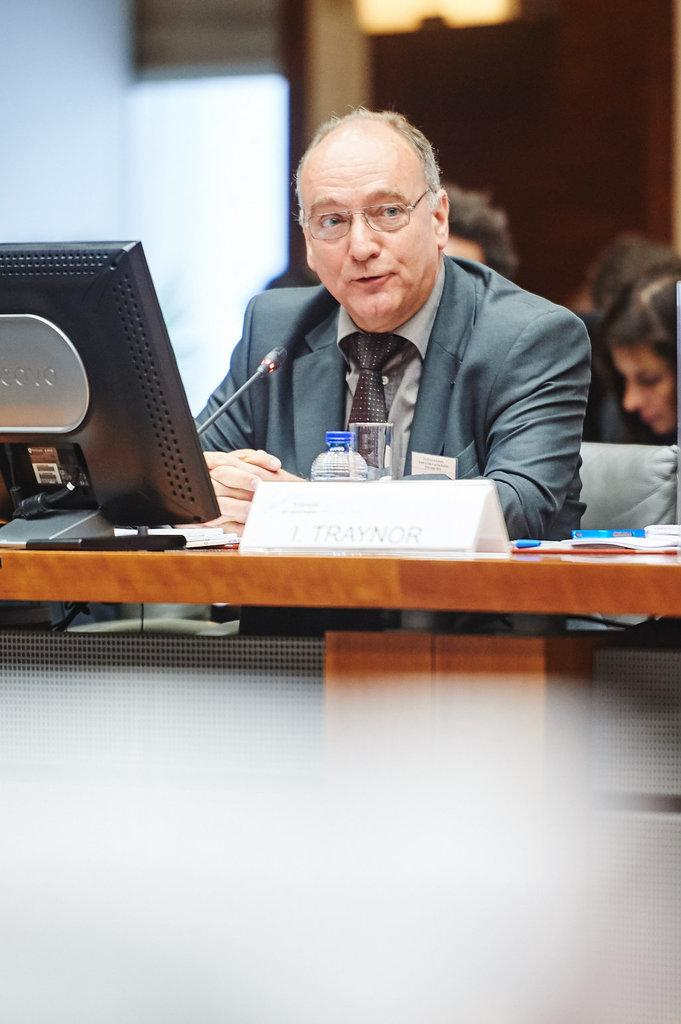What is the man in the image doing? The man is sitting on a chair in the image. What is located on the table in the image? There is a monitor, a bottle, a glass, and a paper on the table in the image. What might the man be using the monitor for? The man might be using the monitor for work, entertainment, or communication. What is the purpose of the glass on the table? The glass on the table might be for drinking water or another beverage. What type of apparel is the baby wearing in the image? There are no babies present in the image, so it is not possible to answer that question. 